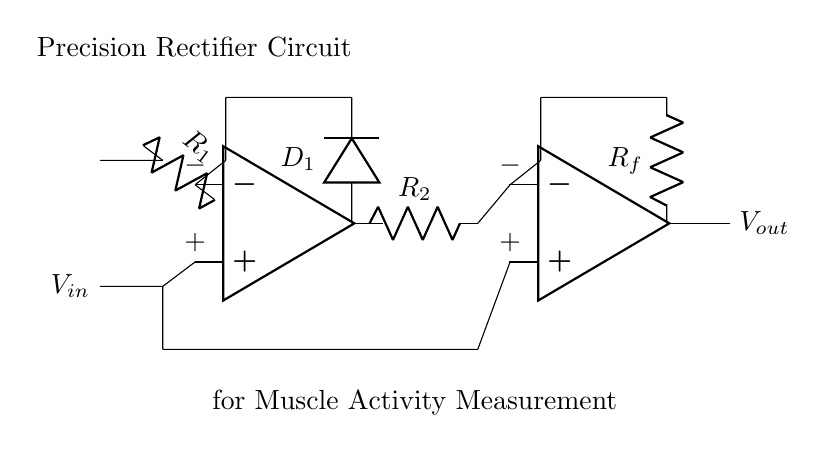What type of rectifier is this circuit? This circuit is a precision rectifier, as indicated by the configuration of operational amplifiers and diodes which allow for accurate measurement of input voltage without the inaccuracies typical of standard rectifiers.
Answer: precision rectifier What are the resistors in the circuit? The resistors present in the circuit are R1, R2, and Rf, which are used to control the gain and feedback of the operational amplifiers for precise output.
Answer: R1, R2, Rf How many operational amplifiers are used in this circuit? The circuit contains two operational amplifiers, as shown in the diagram where each op-amp is labeled distinctly.
Answer: two What is the purpose of the diode D1 in this circuit? The purpose of D1 is to allow current to flow in one direction only, contributing to the rectifying action of the circuit by preventing reverse polarity.
Answer: to allow current flow in one direction What does the feedback resistor Rf do? Rf is a feedback resistor that stabilizes the gain of the second operational amplifier, ensuring that the output voltage is consistent and proportional to the input signal.
Answer: stabilizes the gain How does this circuit improve muscle activity measurement accuracy? The precision rectifier enables accurate measurement of small signals by eliminating the voltage drop across standard diodes, thus ensuring that even low amplitude muscle activity can be effectively captured and measured.
Answer: eliminates diode voltage drop 